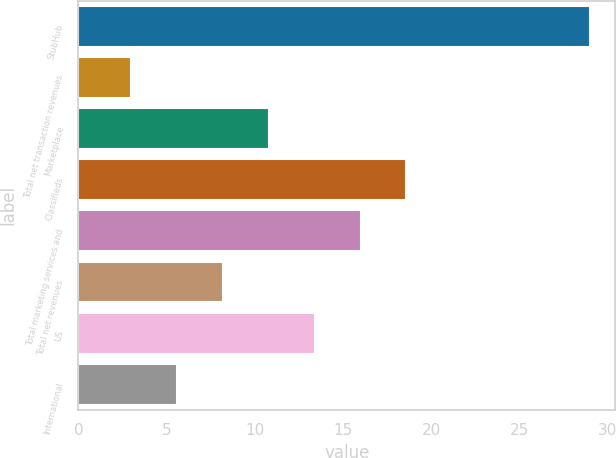Convert chart. <chart><loc_0><loc_0><loc_500><loc_500><bar_chart><fcel>StubHub<fcel>Total net transaction revenues<fcel>Marketplace<fcel>Classifieds<fcel>Total marketing services and<fcel>Total net revenues<fcel>US<fcel>International<nl><fcel>29<fcel>3<fcel>10.8<fcel>18.6<fcel>16<fcel>8.2<fcel>13.4<fcel>5.6<nl></chart> 